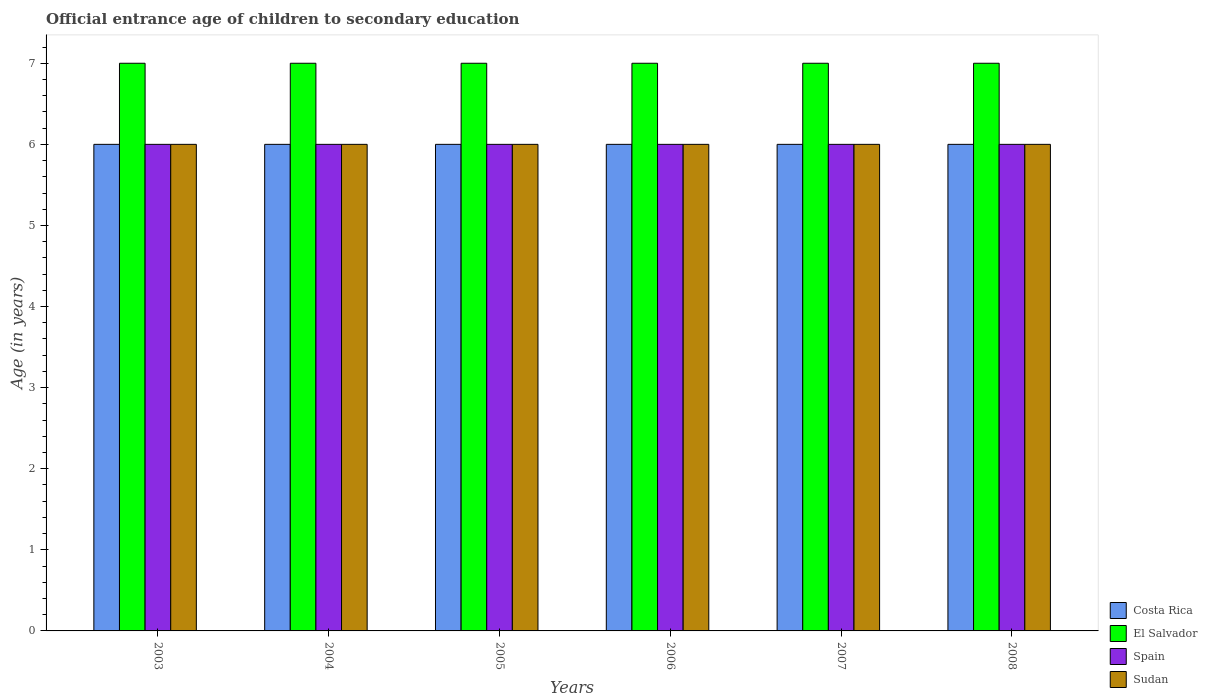How many groups of bars are there?
Keep it short and to the point. 6. Are the number of bars per tick equal to the number of legend labels?
Offer a terse response. Yes. Are the number of bars on each tick of the X-axis equal?
Offer a terse response. Yes. What is the label of the 1st group of bars from the left?
Ensure brevity in your answer.  2003. What is the secondary school starting age of children in El Salvador in 2007?
Offer a very short reply. 7. Across all years, what is the maximum secondary school starting age of children in Sudan?
Your response must be concise. 6. In which year was the secondary school starting age of children in El Salvador minimum?
Your answer should be very brief. 2003. What is the total secondary school starting age of children in El Salvador in the graph?
Your response must be concise. 42. What is the difference between the secondary school starting age of children in El Salvador in 2004 and that in 2006?
Provide a succinct answer. 0. What is the difference between the secondary school starting age of children in Costa Rica in 2005 and the secondary school starting age of children in El Salvador in 2003?
Provide a short and direct response. -1. What is the average secondary school starting age of children in Sudan per year?
Your answer should be very brief. 6. In the year 2005, what is the difference between the secondary school starting age of children in Spain and secondary school starting age of children in El Salvador?
Your answer should be very brief. -1. In how many years, is the secondary school starting age of children in El Salvador greater than 0.2 years?
Your answer should be compact. 6. Is the secondary school starting age of children in Spain in 2003 less than that in 2004?
Provide a succinct answer. No. Is the difference between the secondary school starting age of children in Spain in 2003 and 2004 greater than the difference between the secondary school starting age of children in El Salvador in 2003 and 2004?
Give a very brief answer. No. What is the difference between the highest and the second highest secondary school starting age of children in El Salvador?
Your answer should be very brief. 0. What is the difference between the highest and the lowest secondary school starting age of children in El Salvador?
Your response must be concise. 0. What does the 3rd bar from the left in 2007 represents?
Offer a terse response. Spain. What does the 1st bar from the right in 2003 represents?
Your answer should be very brief. Sudan. Is it the case that in every year, the sum of the secondary school starting age of children in El Salvador and secondary school starting age of children in Sudan is greater than the secondary school starting age of children in Costa Rica?
Keep it short and to the point. Yes. How many bars are there?
Your answer should be very brief. 24. How many years are there in the graph?
Your answer should be very brief. 6. Does the graph contain any zero values?
Keep it short and to the point. No. What is the title of the graph?
Give a very brief answer. Official entrance age of children to secondary education. What is the label or title of the Y-axis?
Ensure brevity in your answer.  Age (in years). What is the Age (in years) in Costa Rica in 2003?
Make the answer very short. 6. What is the Age (in years) of Costa Rica in 2004?
Your response must be concise. 6. What is the Age (in years) of El Salvador in 2004?
Keep it short and to the point. 7. What is the Age (in years) in Spain in 2004?
Give a very brief answer. 6. What is the Age (in years) of Sudan in 2004?
Your answer should be very brief. 6. What is the Age (in years) in Costa Rica in 2005?
Provide a short and direct response. 6. What is the Age (in years) in Sudan in 2005?
Offer a very short reply. 6. What is the Age (in years) of El Salvador in 2006?
Make the answer very short. 7. What is the Age (in years) of Costa Rica in 2007?
Give a very brief answer. 6. What is the Age (in years) in Spain in 2007?
Your answer should be very brief. 6. What is the Age (in years) in Costa Rica in 2008?
Your response must be concise. 6. What is the Age (in years) of El Salvador in 2008?
Provide a succinct answer. 7. What is the Age (in years) of Sudan in 2008?
Give a very brief answer. 6. Across all years, what is the maximum Age (in years) of El Salvador?
Provide a short and direct response. 7. Across all years, what is the maximum Age (in years) in Spain?
Make the answer very short. 6. Across all years, what is the maximum Age (in years) of Sudan?
Your answer should be very brief. 6. Across all years, what is the minimum Age (in years) in El Salvador?
Offer a terse response. 7. What is the total Age (in years) of Costa Rica in the graph?
Your response must be concise. 36. What is the total Age (in years) of Sudan in the graph?
Keep it short and to the point. 36. What is the difference between the Age (in years) of Costa Rica in 2003 and that in 2004?
Ensure brevity in your answer.  0. What is the difference between the Age (in years) of El Salvador in 2003 and that in 2004?
Make the answer very short. 0. What is the difference between the Age (in years) in Costa Rica in 2003 and that in 2006?
Offer a very short reply. 0. What is the difference between the Age (in years) of Sudan in 2003 and that in 2006?
Your response must be concise. 0. What is the difference between the Age (in years) in El Salvador in 2003 and that in 2007?
Offer a terse response. 0. What is the difference between the Age (in years) in Spain in 2003 and that in 2007?
Your answer should be very brief. 0. What is the difference between the Age (in years) in Sudan in 2003 and that in 2007?
Offer a terse response. 0. What is the difference between the Age (in years) of Costa Rica in 2003 and that in 2008?
Make the answer very short. 0. What is the difference between the Age (in years) in Costa Rica in 2004 and that in 2005?
Provide a succinct answer. 0. What is the difference between the Age (in years) of Spain in 2004 and that in 2005?
Your response must be concise. 0. What is the difference between the Age (in years) in Sudan in 2004 and that in 2005?
Offer a very short reply. 0. What is the difference between the Age (in years) of Costa Rica in 2004 and that in 2006?
Your answer should be very brief. 0. What is the difference between the Age (in years) in El Salvador in 2004 and that in 2006?
Provide a short and direct response. 0. What is the difference between the Age (in years) in Sudan in 2004 and that in 2006?
Offer a terse response. 0. What is the difference between the Age (in years) of El Salvador in 2004 and that in 2007?
Provide a succinct answer. 0. What is the difference between the Age (in years) in Costa Rica in 2004 and that in 2008?
Provide a succinct answer. 0. What is the difference between the Age (in years) of Sudan in 2004 and that in 2008?
Ensure brevity in your answer.  0. What is the difference between the Age (in years) of Costa Rica in 2005 and that in 2006?
Offer a terse response. 0. What is the difference between the Age (in years) in El Salvador in 2005 and that in 2006?
Your response must be concise. 0. What is the difference between the Age (in years) of Spain in 2005 and that in 2006?
Provide a succinct answer. 0. What is the difference between the Age (in years) of Sudan in 2005 and that in 2006?
Ensure brevity in your answer.  0. What is the difference between the Age (in years) of Costa Rica in 2005 and that in 2007?
Provide a succinct answer. 0. What is the difference between the Age (in years) in Sudan in 2005 and that in 2007?
Your answer should be compact. 0. What is the difference between the Age (in years) of El Salvador in 2005 and that in 2008?
Keep it short and to the point. 0. What is the difference between the Age (in years) of Costa Rica in 2006 and that in 2007?
Ensure brevity in your answer.  0. What is the difference between the Age (in years) in El Salvador in 2006 and that in 2007?
Provide a succinct answer. 0. What is the difference between the Age (in years) in Sudan in 2006 and that in 2007?
Keep it short and to the point. 0. What is the difference between the Age (in years) of Costa Rica in 2006 and that in 2008?
Provide a succinct answer. 0. What is the difference between the Age (in years) of Costa Rica in 2007 and that in 2008?
Offer a terse response. 0. What is the difference between the Age (in years) in Spain in 2007 and that in 2008?
Your answer should be compact. 0. What is the difference between the Age (in years) in Sudan in 2007 and that in 2008?
Keep it short and to the point. 0. What is the difference between the Age (in years) in El Salvador in 2003 and the Age (in years) in Spain in 2004?
Provide a short and direct response. 1. What is the difference between the Age (in years) in El Salvador in 2003 and the Age (in years) in Sudan in 2004?
Your answer should be compact. 1. What is the difference between the Age (in years) of Costa Rica in 2003 and the Age (in years) of El Salvador in 2005?
Keep it short and to the point. -1. What is the difference between the Age (in years) in Costa Rica in 2003 and the Age (in years) in Spain in 2005?
Give a very brief answer. 0. What is the difference between the Age (in years) of Costa Rica in 2003 and the Age (in years) of Sudan in 2005?
Give a very brief answer. 0. What is the difference between the Age (in years) in Costa Rica in 2003 and the Age (in years) in El Salvador in 2006?
Your answer should be very brief. -1. What is the difference between the Age (in years) of Costa Rica in 2003 and the Age (in years) of Sudan in 2006?
Make the answer very short. 0. What is the difference between the Age (in years) in El Salvador in 2003 and the Age (in years) in Spain in 2006?
Make the answer very short. 1. What is the difference between the Age (in years) of Spain in 2003 and the Age (in years) of Sudan in 2006?
Offer a very short reply. 0. What is the difference between the Age (in years) of Costa Rica in 2003 and the Age (in years) of El Salvador in 2007?
Give a very brief answer. -1. What is the difference between the Age (in years) of Costa Rica in 2003 and the Age (in years) of Spain in 2007?
Provide a short and direct response. 0. What is the difference between the Age (in years) of Costa Rica in 2003 and the Age (in years) of Sudan in 2007?
Provide a succinct answer. 0. What is the difference between the Age (in years) in El Salvador in 2003 and the Age (in years) in Sudan in 2007?
Provide a short and direct response. 1. What is the difference between the Age (in years) of Spain in 2003 and the Age (in years) of Sudan in 2007?
Your response must be concise. 0. What is the difference between the Age (in years) in Costa Rica in 2004 and the Age (in years) in El Salvador in 2005?
Your response must be concise. -1. What is the difference between the Age (in years) in Costa Rica in 2004 and the Age (in years) in Spain in 2005?
Offer a terse response. 0. What is the difference between the Age (in years) of Costa Rica in 2004 and the Age (in years) of Sudan in 2005?
Make the answer very short. 0. What is the difference between the Age (in years) of El Salvador in 2004 and the Age (in years) of Spain in 2005?
Provide a succinct answer. 1. What is the difference between the Age (in years) of El Salvador in 2004 and the Age (in years) of Sudan in 2005?
Your answer should be compact. 1. What is the difference between the Age (in years) of Costa Rica in 2004 and the Age (in years) of El Salvador in 2006?
Make the answer very short. -1. What is the difference between the Age (in years) of Costa Rica in 2004 and the Age (in years) of Sudan in 2006?
Provide a succinct answer. 0. What is the difference between the Age (in years) of El Salvador in 2004 and the Age (in years) of Sudan in 2006?
Offer a very short reply. 1. What is the difference between the Age (in years) of Costa Rica in 2004 and the Age (in years) of El Salvador in 2007?
Ensure brevity in your answer.  -1. What is the difference between the Age (in years) in Costa Rica in 2004 and the Age (in years) in Spain in 2007?
Give a very brief answer. 0. What is the difference between the Age (in years) in El Salvador in 2004 and the Age (in years) in Sudan in 2007?
Offer a terse response. 1. What is the difference between the Age (in years) of Spain in 2004 and the Age (in years) of Sudan in 2007?
Give a very brief answer. 0. What is the difference between the Age (in years) of Costa Rica in 2004 and the Age (in years) of Spain in 2008?
Provide a short and direct response. 0. What is the difference between the Age (in years) of Costa Rica in 2004 and the Age (in years) of Sudan in 2008?
Provide a short and direct response. 0. What is the difference between the Age (in years) in Spain in 2004 and the Age (in years) in Sudan in 2008?
Offer a terse response. 0. What is the difference between the Age (in years) of Costa Rica in 2005 and the Age (in years) of El Salvador in 2006?
Offer a very short reply. -1. What is the difference between the Age (in years) in El Salvador in 2005 and the Age (in years) in Spain in 2006?
Your answer should be very brief. 1. What is the difference between the Age (in years) of Spain in 2005 and the Age (in years) of Sudan in 2006?
Offer a very short reply. 0. What is the difference between the Age (in years) of Costa Rica in 2005 and the Age (in years) of El Salvador in 2007?
Your response must be concise. -1. What is the difference between the Age (in years) of El Salvador in 2005 and the Age (in years) of Sudan in 2007?
Offer a very short reply. 1. What is the difference between the Age (in years) of Spain in 2005 and the Age (in years) of Sudan in 2007?
Ensure brevity in your answer.  0. What is the difference between the Age (in years) of Costa Rica in 2005 and the Age (in years) of Spain in 2008?
Your response must be concise. 0. What is the difference between the Age (in years) of Costa Rica in 2005 and the Age (in years) of Sudan in 2008?
Your answer should be compact. 0. What is the difference between the Age (in years) of El Salvador in 2005 and the Age (in years) of Spain in 2008?
Provide a succinct answer. 1. What is the difference between the Age (in years) of El Salvador in 2005 and the Age (in years) of Sudan in 2008?
Make the answer very short. 1. What is the difference between the Age (in years) of Spain in 2005 and the Age (in years) of Sudan in 2008?
Provide a short and direct response. 0. What is the difference between the Age (in years) of Costa Rica in 2006 and the Age (in years) of El Salvador in 2007?
Your response must be concise. -1. What is the difference between the Age (in years) of Costa Rica in 2006 and the Age (in years) of Spain in 2007?
Your answer should be compact. 0. What is the difference between the Age (in years) in Spain in 2006 and the Age (in years) in Sudan in 2007?
Offer a terse response. 0. What is the difference between the Age (in years) of Costa Rica in 2007 and the Age (in years) of Sudan in 2008?
Make the answer very short. 0. What is the difference between the Age (in years) of El Salvador in 2007 and the Age (in years) of Sudan in 2008?
Ensure brevity in your answer.  1. What is the difference between the Age (in years) in Spain in 2007 and the Age (in years) in Sudan in 2008?
Make the answer very short. 0. What is the average Age (in years) of El Salvador per year?
Offer a very short reply. 7. What is the average Age (in years) in Spain per year?
Your answer should be very brief. 6. In the year 2003, what is the difference between the Age (in years) of Costa Rica and Age (in years) of El Salvador?
Make the answer very short. -1. In the year 2003, what is the difference between the Age (in years) in Costa Rica and Age (in years) in Sudan?
Offer a terse response. 0. In the year 2004, what is the difference between the Age (in years) of Costa Rica and Age (in years) of El Salvador?
Your response must be concise. -1. In the year 2004, what is the difference between the Age (in years) of Costa Rica and Age (in years) of Sudan?
Provide a succinct answer. 0. In the year 2004, what is the difference between the Age (in years) of El Salvador and Age (in years) of Sudan?
Ensure brevity in your answer.  1. In the year 2005, what is the difference between the Age (in years) in Costa Rica and Age (in years) in El Salvador?
Your answer should be very brief. -1. In the year 2005, what is the difference between the Age (in years) in Costa Rica and Age (in years) in Spain?
Offer a very short reply. 0. In the year 2005, what is the difference between the Age (in years) of Costa Rica and Age (in years) of Sudan?
Make the answer very short. 0. In the year 2005, what is the difference between the Age (in years) in El Salvador and Age (in years) in Spain?
Provide a succinct answer. 1. In the year 2006, what is the difference between the Age (in years) of Costa Rica and Age (in years) of Sudan?
Give a very brief answer. 0. In the year 2006, what is the difference between the Age (in years) of Spain and Age (in years) of Sudan?
Make the answer very short. 0. In the year 2007, what is the difference between the Age (in years) of El Salvador and Age (in years) of Spain?
Make the answer very short. 1. In the year 2008, what is the difference between the Age (in years) in Costa Rica and Age (in years) in El Salvador?
Offer a terse response. -1. In the year 2008, what is the difference between the Age (in years) in Costa Rica and Age (in years) in Spain?
Give a very brief answer. 0. In the year 2008, what is the difference between the Age (in years) of Costa Rica and Age (in years) of Sudan?
Your answer should be compact. 0. In the year 2008, what is the difference between the Age (in years) of Spain and Age (in years) of Sudan?
Ensure brevity in your answer.  0. What is the ratio of the Age (in years) in Spain in 2003 to that in 2004?
Make the answer very short. 1. What is the ratio of the Age (in years) in Sudan in 2003 to that in 2004?
Keep it short and to the point. 1. What is the ratio of the Age (in years) of El Salvador in 2003 to that in 2005?
Make the answer very short. 1. What is the ratio of the Age (in years) in Spain in 2003 to that in 2005?
Your response must be concise. 1. What is the ratio of the Age (in years) of Sudan in 2003 to that in 2005?
Provide a succinct answer. 1. What is the ratio of the Age (in years) of Costa Rica in 2003 to that in 2006?
Your response must be concise. 1. What is the ratio of the Age (in years) in Sudan in 2003 to that in 2006?
Ensure brevity in your answer.  1. What is the ratio of the Age (in years) of El Salvador in 2003 to that in 2007?
Your answer should be very brief. 1. What is the ratio of the Age (in years) in Spain in 2003 to that in 2007?
Provide a short and direct response. 1. What is the ratio of the Age (in years) of Costa Rica in 2003 to that in 2008?
Your answer should be very brief. 1. What is the ratio of the Age (in years) of El Salvador in 2003 to that in 2008?
Ensure brevity in your answer.  1. What is the ratio of the Age (in years) of Spain in 2003 to that in 2008?
Your answer should be compact. 1. What is the ratio of the Age (in years) in Sudan in 2003 to that in 2008?
Offer a very short reply. 1. What is the ratio of the Age (in years) of Sudan in 2004 to that in 2005?
Give a very brief answer. 1. What is the ratio of the Age (in years) in Costa Rica in 2004 to that in 2006?
Make the answer very short. 1. What is the ratio of the Age (in years) in Spain in 2004 to that in 2006?
Give a very brief answer. 1. What is the ratio of the Age (in years) of Sudan in 2004 to that in 2006?
Your answer should be very brief. 1. What is the ratio of the Age (in years) in Costa Rica in 2004 to that in 2007?
Provide a short and direct response. 1. What is the ratio of the Age (in years) of Spain in 2004 to that in 2007?
Provide a short and direct response. 1. What is the ratio of the Age (in years) in Sudan in 2004 to that in 2007?
Offer a very short reply. 1. What is the ratio of the Age (in years) of Costa Rica in 2005 to that in 2006?
Make the answer very short. 1. What is the ratio of the Age (in years) of Sudan in 2005 to that in 2006?
Your answer should be compact. 1. What is the ratio of the Age (in years) of Sudan in 2005 to that in 2007?
Give a very brief answer. 1. What is the ratio of the Age (in years) of Costa Rica in 2005 to that in 2008?
Give a very brief answer. 1. What is the ratio of the Age (in years) in El Salvador in 2005 to that in 2008?
Your response must be concise. 1. What is the ratio of the Age (in years) of Sudan in 2005 to that in 2008?
Offer a terse response. 1. What is the ratio of the Age (in years) of Costa Rica in 2006 to that in 2007?
Your answer should be compact. 1. What is the ratio of the Age (in years) in Costa Rica in 2006 to that in 2008?
Offer a very short reply. 1. What is the ratio of the Age (in years) of Spain in 2006 to that in 2008?
Your answer should be very brief. 1. What is the ratio of the Age (in years) of El Salvador in 2007 to that in 2008?
Offer a very short reply. 1. What is the ratio of the Age (in years) of Spain in 2007 to that in 2008?
Your response must be concise. 1. What is the ratio of the Age (in years) in Sudan in 2007 to that in 2008?
Your answer should be very brief. 1. What is the difference between the highest and the second highest Age (in years) of Costa Rica?
Keep it short and to the point. 0. What is the difference between the highest and the second highest Age (in years) in El Salvador?
Provide a succinct answer. 0. What is the difference between the highest and the second highest Age (in years) of Spain?
Give a very brief answer. 0. What is the difference between the highest and the lowest Age (in years) in Costa Rica?
Offer a very short reply. 0. What is the difference between the highest and the lowest Age (in years) in Spain?
Your answer should be very brief. 0. 